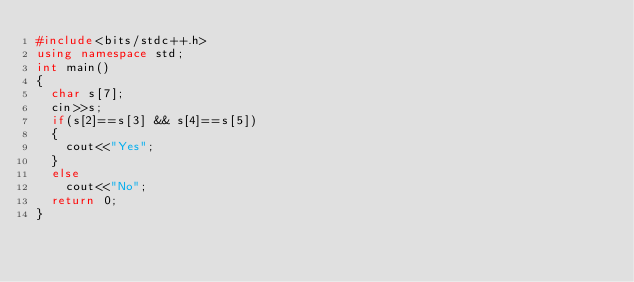<code> <loc_0><loc_0><loc_500><loc_500><_C++_>#include<bits/stdc++.h>
using namespace std;
int main()
{
	char s[7];
	cin>>s;
	if(s[2]==s[3] && s[4]==s[5])
	{
		cout<<"Yes";
	}
	else
		cout<<"No";
	return 0;
}</code> 